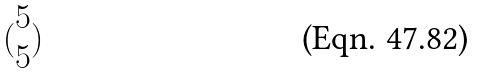Convert formula to latex. <formula><loc_0><loc_0><loc_500><loc_500>( \begin{matrix} 5 \\ 5 \end{matrix} )</formula> 